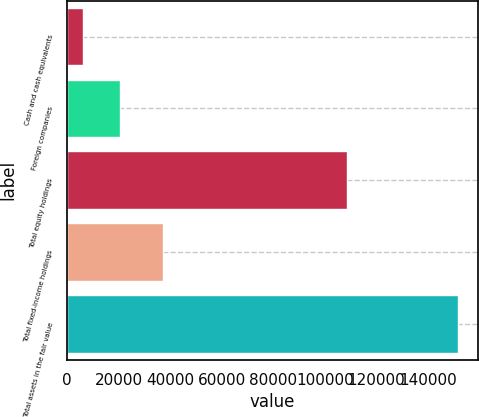Convert chart. <chart><loc_0><loc_0><loc_500><loc_500><bar_chart><fcel>Cash and cash equivalents<fcel>Foreign companies<fcel>Total equity holdings<fcel>Total fixed-income holdings<fcel>Total assets in the fair value<nl><fcel>6068<fcel>20648.6<fcel>108771<fcel>37035<fcel>151874<nl></chart> 